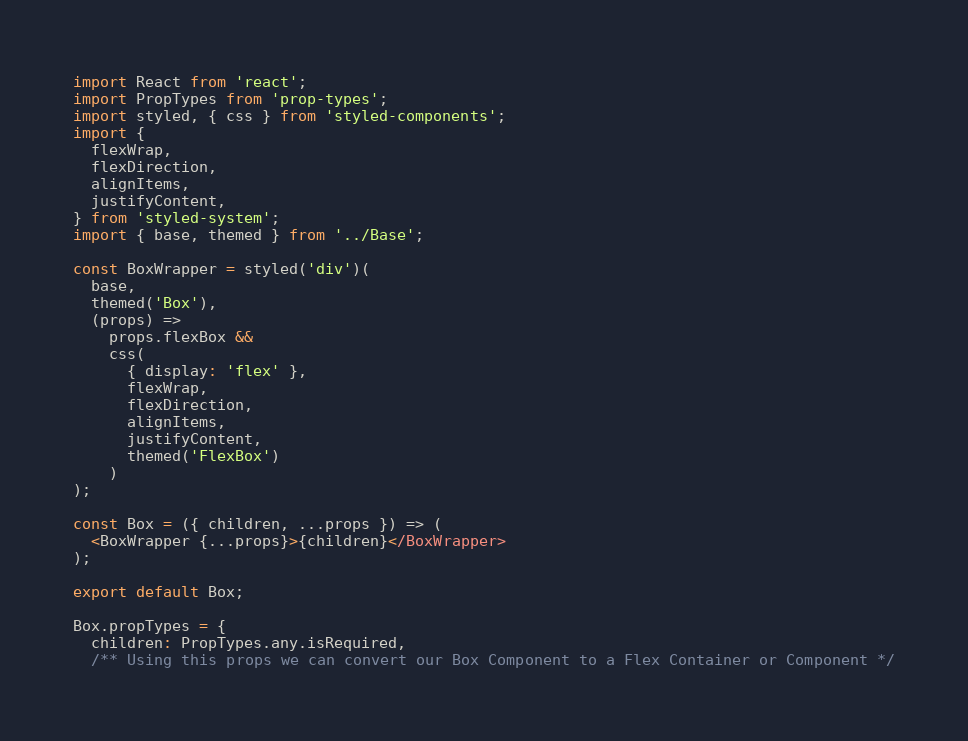Convert code to text. <code><loc_0><loc_0><loc_500><loc_500><_JavaScript_>import React from 'react';
import PropTypes from 'prop-types';
import styled, { css } from 'styled-components';
import {
  flexWrap,
  flexDirection,
  alignItems,
  justifyContent,
} from 'styled-system';
import { base, themed } from '../Base';

const BoxWrapper = styled('div')(
  base,
  themed('Box'),
  (props) =>
    props.flexBox &&
    css(
      { display: 'flex' },
      flexWrap,
      flexDirection,
      alignItems,
      justifyContent,
      themed('FlexBox')
    )
);

const Box = ({ children, ...props }) => (
  <BoxWrapper {...props}>{children}</BoxWrapper>
);

export default Box;

Box.propTypes = {
  children: PropTypes.any.isRequired,
  /** Using this props we can convert our Box Component to a Flex Container or Component */</code> 